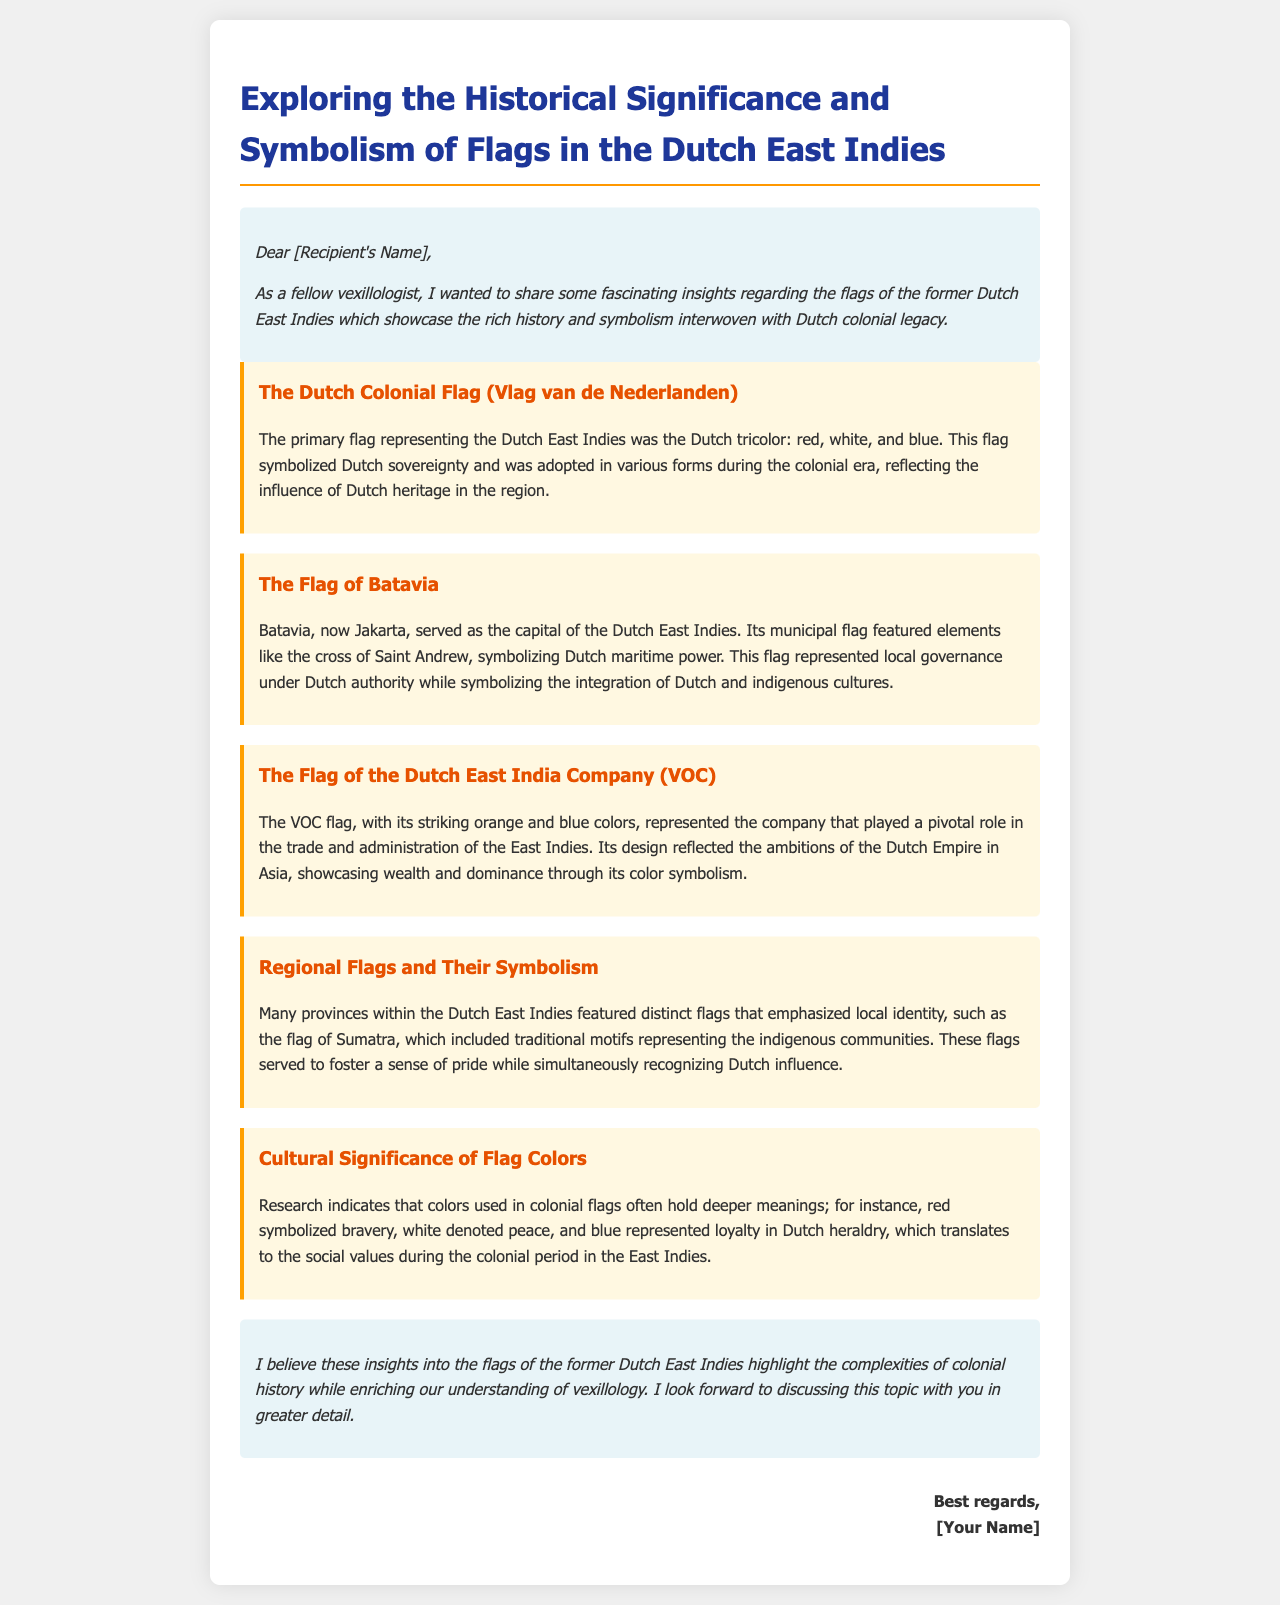What is the primary flag representing the Dutch East Indies? The document states that the primary flag was the Dutch tricolor: red, white, and blue.
Answer: Dutch tricolor What city served as the capital of the Dutch East Indies? The capital city mentioned in the document is Batavia, which is now Jakarta.
Answer: Batavia What colors are used in the flag of the Dutch East India Company (VOC)? The document describes the VOC flag as having striking orange and blue colors.
Answer: Orange and blue What does red symbolize in Dutch heraldry according to the document? The document notes that red symbolizes bravery in Dutch heraldry.
Answer: Bravery How did the Flag of Batavia symbolize local governance? The document explains that the flag featured elements like the cross of Saint Andrew, reflecting Dutch maritime power and governance.
Answer: Cross of Saint Andrew What was the purpose of regional flags in the Dutch East Indies? The document states that regional flags emphasized local identity and fostered a sense of pride while recognizing Dutch influence.
Answer: Foster pride What overarching theme does the document suggest about flags of the Dutch East Indies? The document highlights that the flags showcase the complexities of colonial history.
Answer: Complexities of colonial history What is the intended audience of the email? The introduction of the document reveals that the email is intended for a fellow vexillologist.
Answer: Fellow vexillologist What is one characteristic of the findings section in the email? The findings section is characterized by presenting different flags and their symbolic meanings.
Answer: Symbolic meanings 